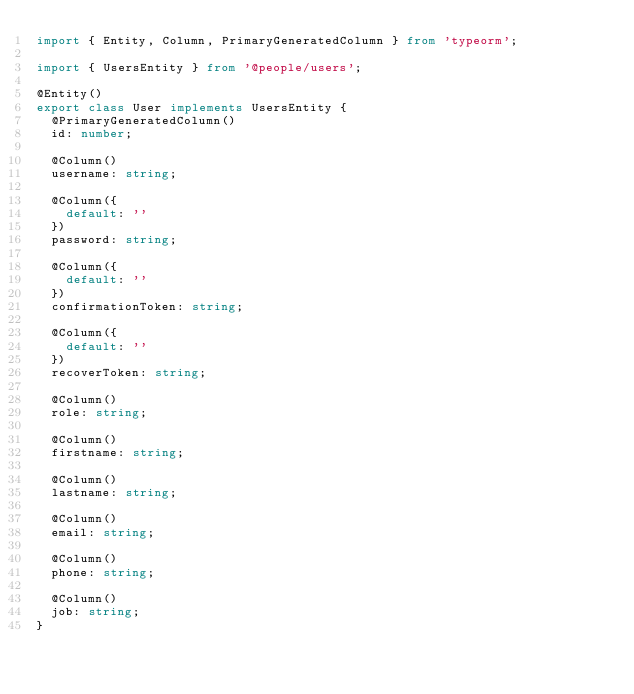Convert code to text. <code><loc_0><loc_0><loc_500><loc_500><_TypeScript_>import { Entity, Column, PrimaryGeneratedColumn } from 'typeorm';

import { UsersEntity } from '@people/users';

@Entity()
export class User implements UsersEntity {
  @PrimaryGeneratedColumn()
  id: number;

  @Column()
  username: string;

  @Column({
    default: ''
  })
  password: string;

  @Column({
    default: ''
  })
  confirmationToken: string;

  @Column({
    default: ''
  })
  recoverToken: string;

  @Column()
  role: string;

  @Column()
  firstname: string;

  @Column()
  lastname: string;

  @Column()
  email: string;

  @Column()
  phone: string;

  @Column()
  job: string;
}
</code> 